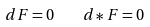<formula> <loc_0><loc_0><loc_500><loc_500>d F = 0 \quad d * F = 0</formula> 